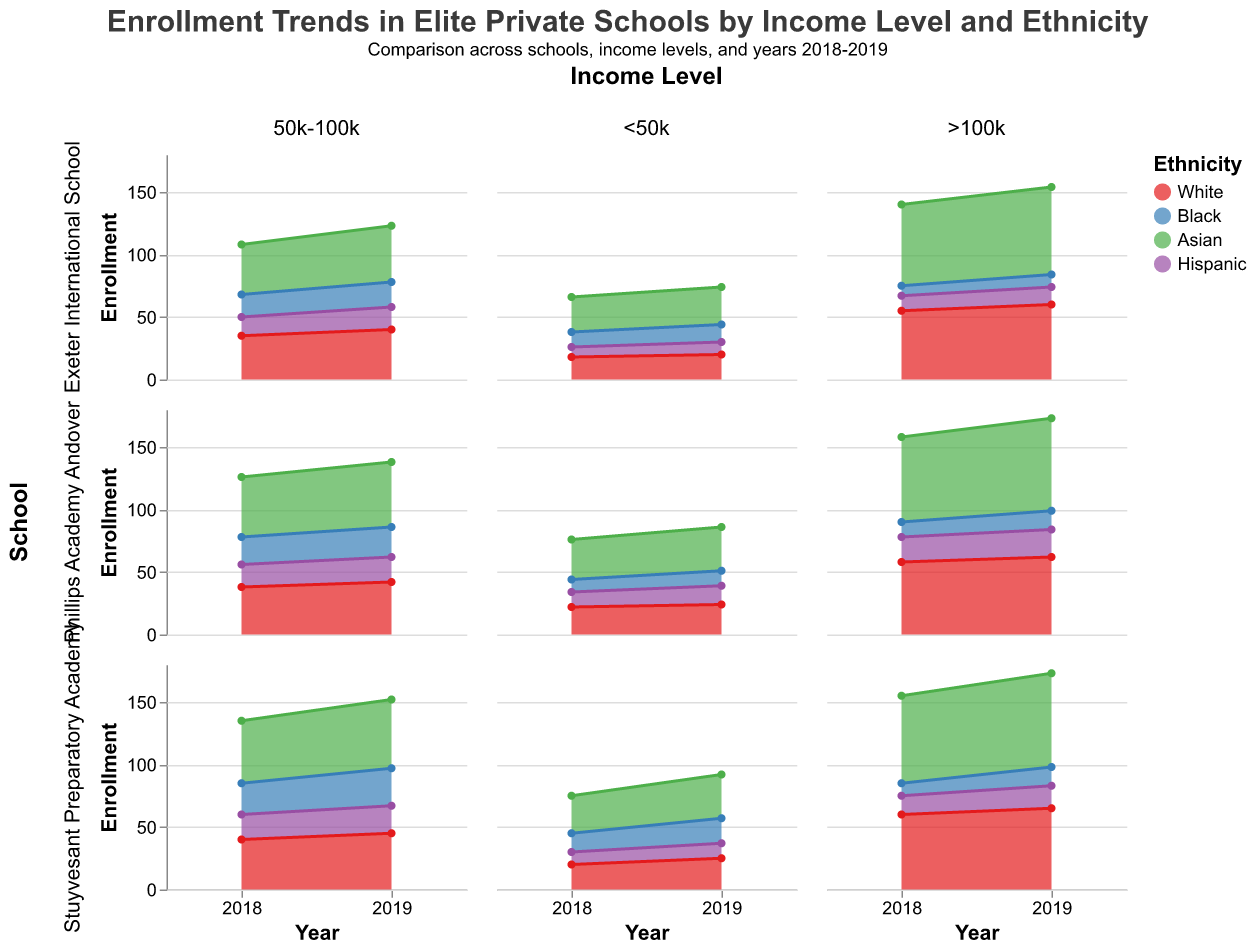What is the title of the figure? The title of the figure is located at the top center of the plot.
Answer: Enrollment Trends in Elite Private Schools by Income Level and Ethnicity Which ethnicity had the highest enrollment in Stuyvesant Preparatory Academy for the >100k income level in 2019? First, locate the subplot for Stuyvesant Preparatory Academy and filter for the >100k income level in the year 2019. Then, identify the ethnicity with the highest area under the curve.
Answer: Asian How did the enrollment of Hispanic students with <50k income change from 2018 to 2019 in Exeter International School? Focus on Exeter International School and locate the <50k income level for the years 2018 and 2019. Compare the enrollment of Hispanic students for these two years.
Answer: Increased by 2 Which school had the highest total enrollment for Asian students across all income levels in 2019? Sum the enrollment of Asian students across all income levels for each school in 2019 and identify the school with the highest total.
Answer: Stuyvesant Preparatory Academy Compare the enrollment trends of Black students from 2018 to 2019 in Phillips Academy Andover for the 50k-100k income level. Identify the subplots related to Phillips Academy Andover and the 50k-100k income level for the years 2018 and 2019. Compare the black student enrollments between these two years.
Answer: Increased from 22 to 24 What is the total enrollment for White students in Stuyvesant Preparatory Academy for all income levels in 2018? Sum the enrollment of White students across all income levels in Stuyvesant Preparatory Academy for the year 2018.
Answer: 120 How does the enrollment of Asian students compare between Exeter International School and Phillips Academy Andover in 2019 for the >100k income level? Locate the >100k income level subplot for both schools in 2019 and compare the enrollment figures of Asian students.
Answer: Exeter International School: 70, Phillips Academy Andover: 74 Which school's Hispanic student enrollment for the <50k income level remained constant from 2018 to 2019? Evaluate the subplots for the <50k income level across the years 2018 and 2019 and determine which school shows no change in Hispanic student enrollment.
Answer: Phillips Academy Andover What is the trend in total enrollment of Asian students in Stuyvesant Preparatory Academy from 2018 to 2019 for <50k and >100k income levels combined? Combine the enrollments for <50k and >100k income levels for Asian students in Stuyvesant Preparatory Academy for 2018 and 2019, then analyze the trend.
Answer: Increased Compare the enrollment of White students in Exeter International School to Phillips Academy Andover for 2018 at the 50k-100k income level. Find the 50k-100k income level subplot for both schools in 2018 and compare the enrollment figures for White students.
Answer: Exeter International School: 35, Phillips Academy Andover: 38 